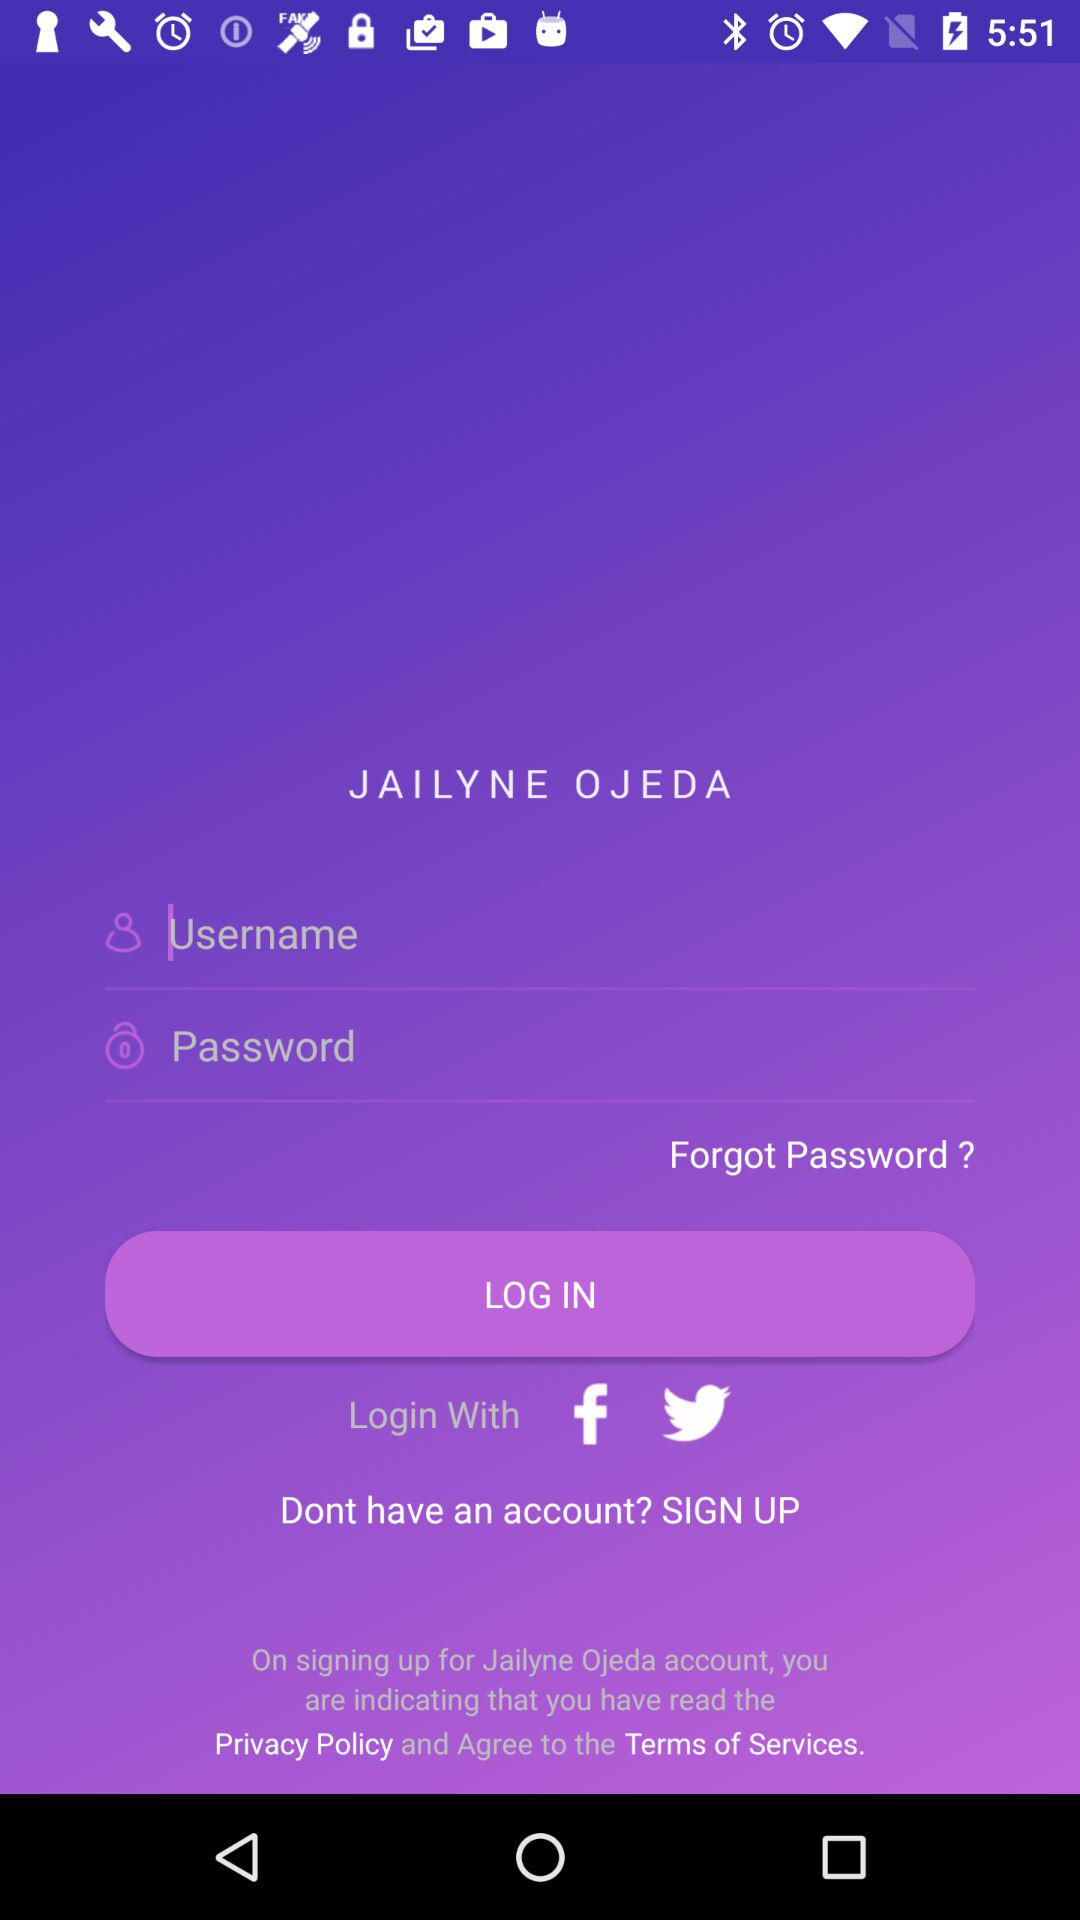What is the name of the application? The name of the application is "JAILYNE OJEDA". 